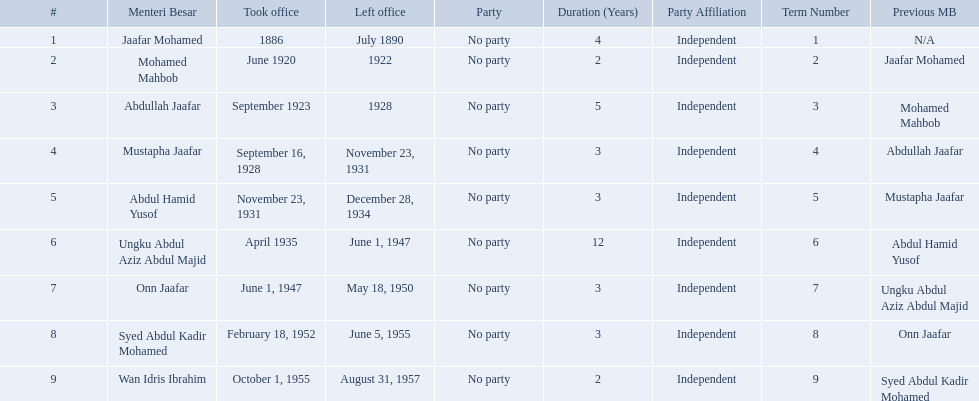Which menteri besars took office in the 1920's? Mohamed Mahbob, Abdullah Jaafar, Mustapha Jaafar. Of those men, who was only in office for 2 years? Mohamed Mahbob. 